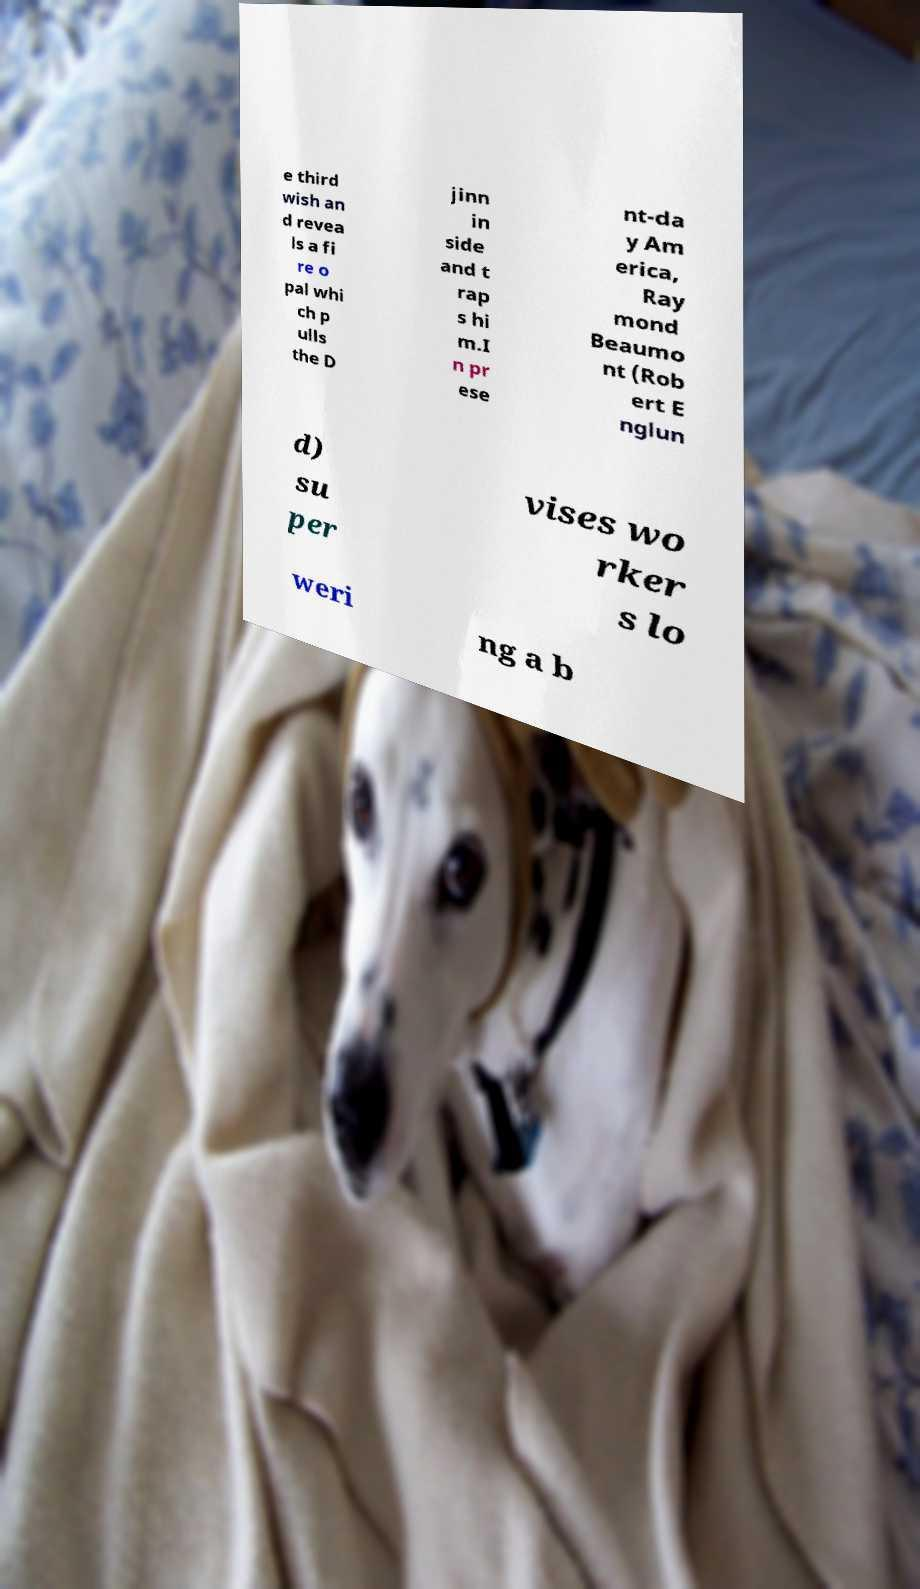Can you read and provide the text displayed in the image?This photo seems to have some interesting text. Can you extract and type it out for me? e third wish an d revea ls a fi re o pal whi ch p ulls the D jinn in side and t rap s hi m.I n pr ese nt-da y Am erica, Ray mond Beaumo nt (Rob ert E nglun d) su per vises wo rker s lo weri ng a b 